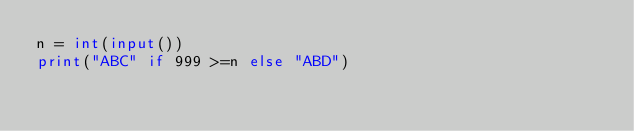<code> <loc_0><loc_0><loc_500><loc_500><_Python_>n = int(input())
print("ABC" if 999 >=n else "ABD")</code> 